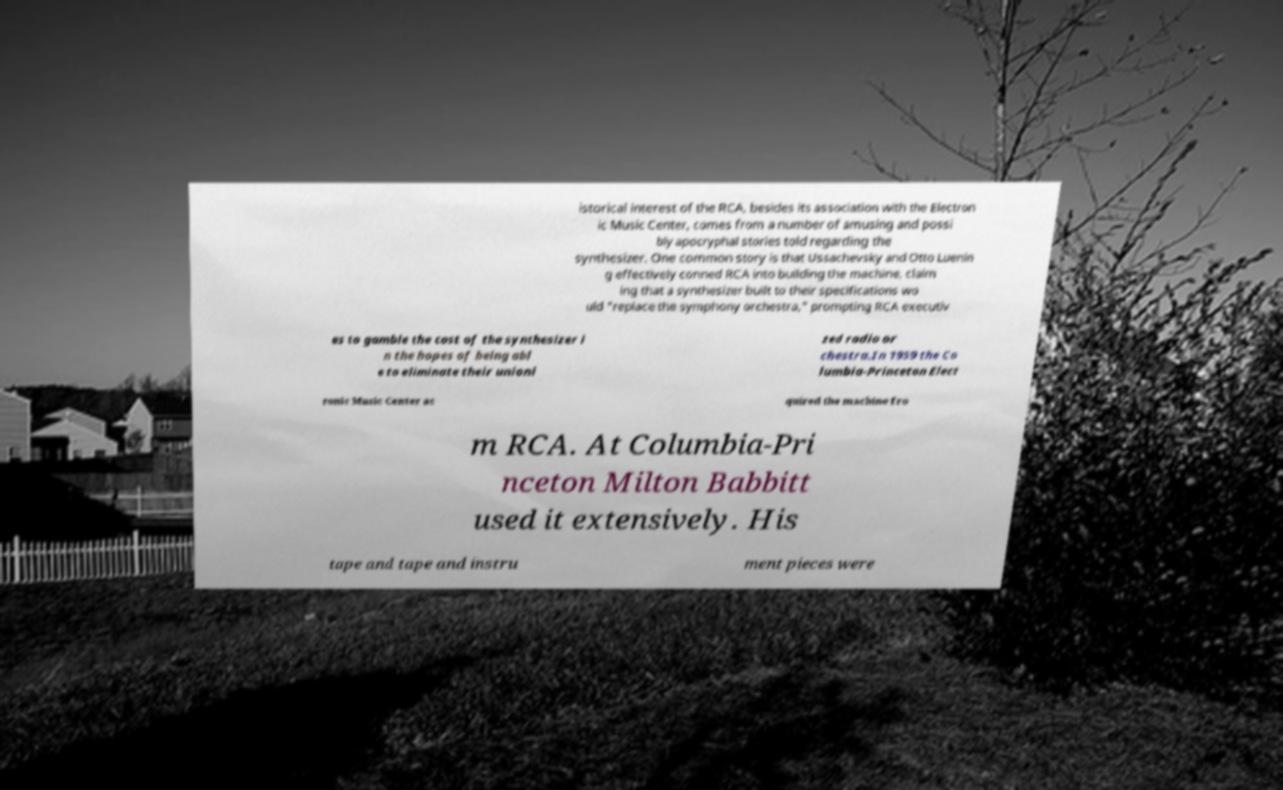For documentation purposes, I need the text within this image transcribed. Could you provide that? istorical interest of the RCA, besides its association with the Electron ic Music Center, comes from a number of amusing and possi bly apocryphal stories told regarding the synthesizer. One common story is that Ussachevsky and Otto Luenin g effectively conned RCA into building the machine, claim ing that a synthesizer built to their specifications wo uld "replace the symphony orchestra," prompting RCA executiv es to gamble the cost of the synthesizer i n the hopes of being abl e to eliminate their unioni zed radio or chestra.In 1959 the Co lumbia-Princeton Elect ronic Music Center ac quired the machine fro m RCA. At Columbia-Pri nceton Milton Babbitt used it extensively. His tape and tape and instru ment pieces were 